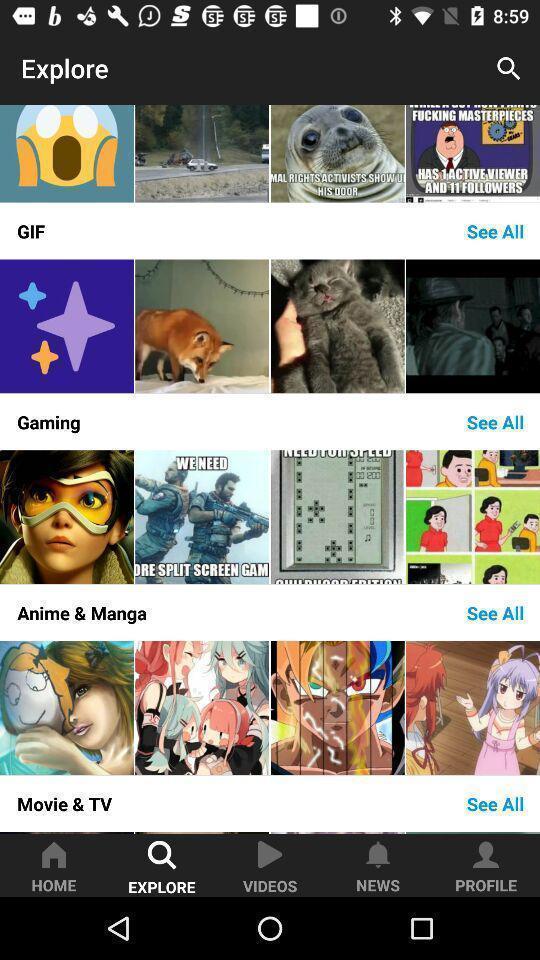Provide a detailed account of this screenshot. Page showing the various categories in explores tabs. 